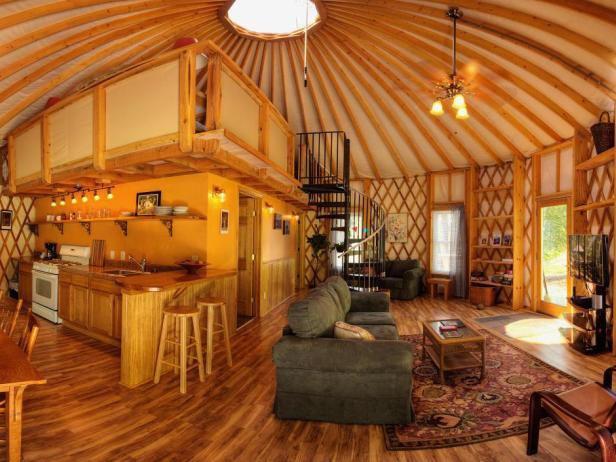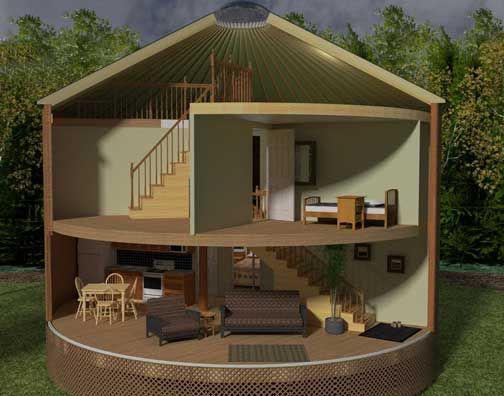The first image is the image on the left, the second image is the image on the right. Given the left and right images, does the statement "In the right image there is a staircase on the left leading up right towards the center." hold true? Answer yes or no. Yes. 